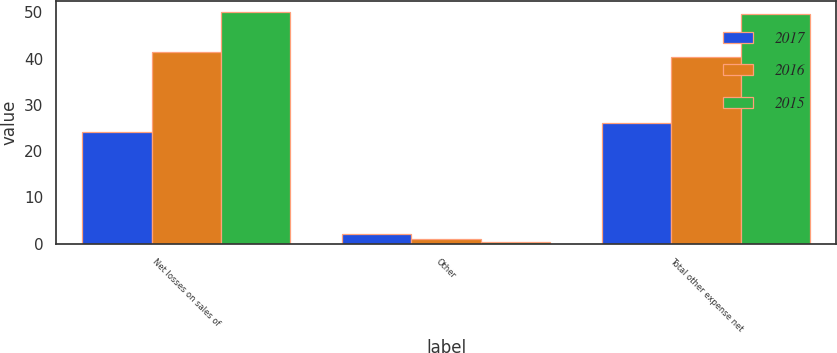Convert chart. <chart><loc_0><loc_0><loc_500><loc_500><stacked_bar_chart><ecel><fcel>Net losses on sales of<fcel>Other<fcel>Total other expense net<nl><fcel>2017<fcel>24.1<fcel>2.1<fcel>26.2<nl><fcel>2016<fcel>41.4<fcel>1.1<fcel>40.3<nl><fcel>2015<fcel>50<fcel>0.4<fcel>49.6<nl></chart> 